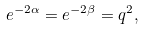Convert formula to latex. <formula><loc_0><loc_0><loc_500><loc_500>e ^ { - 2 \alpha } = e ^ { - 2 \beta } = q ^ { 2 } ,</formula> 